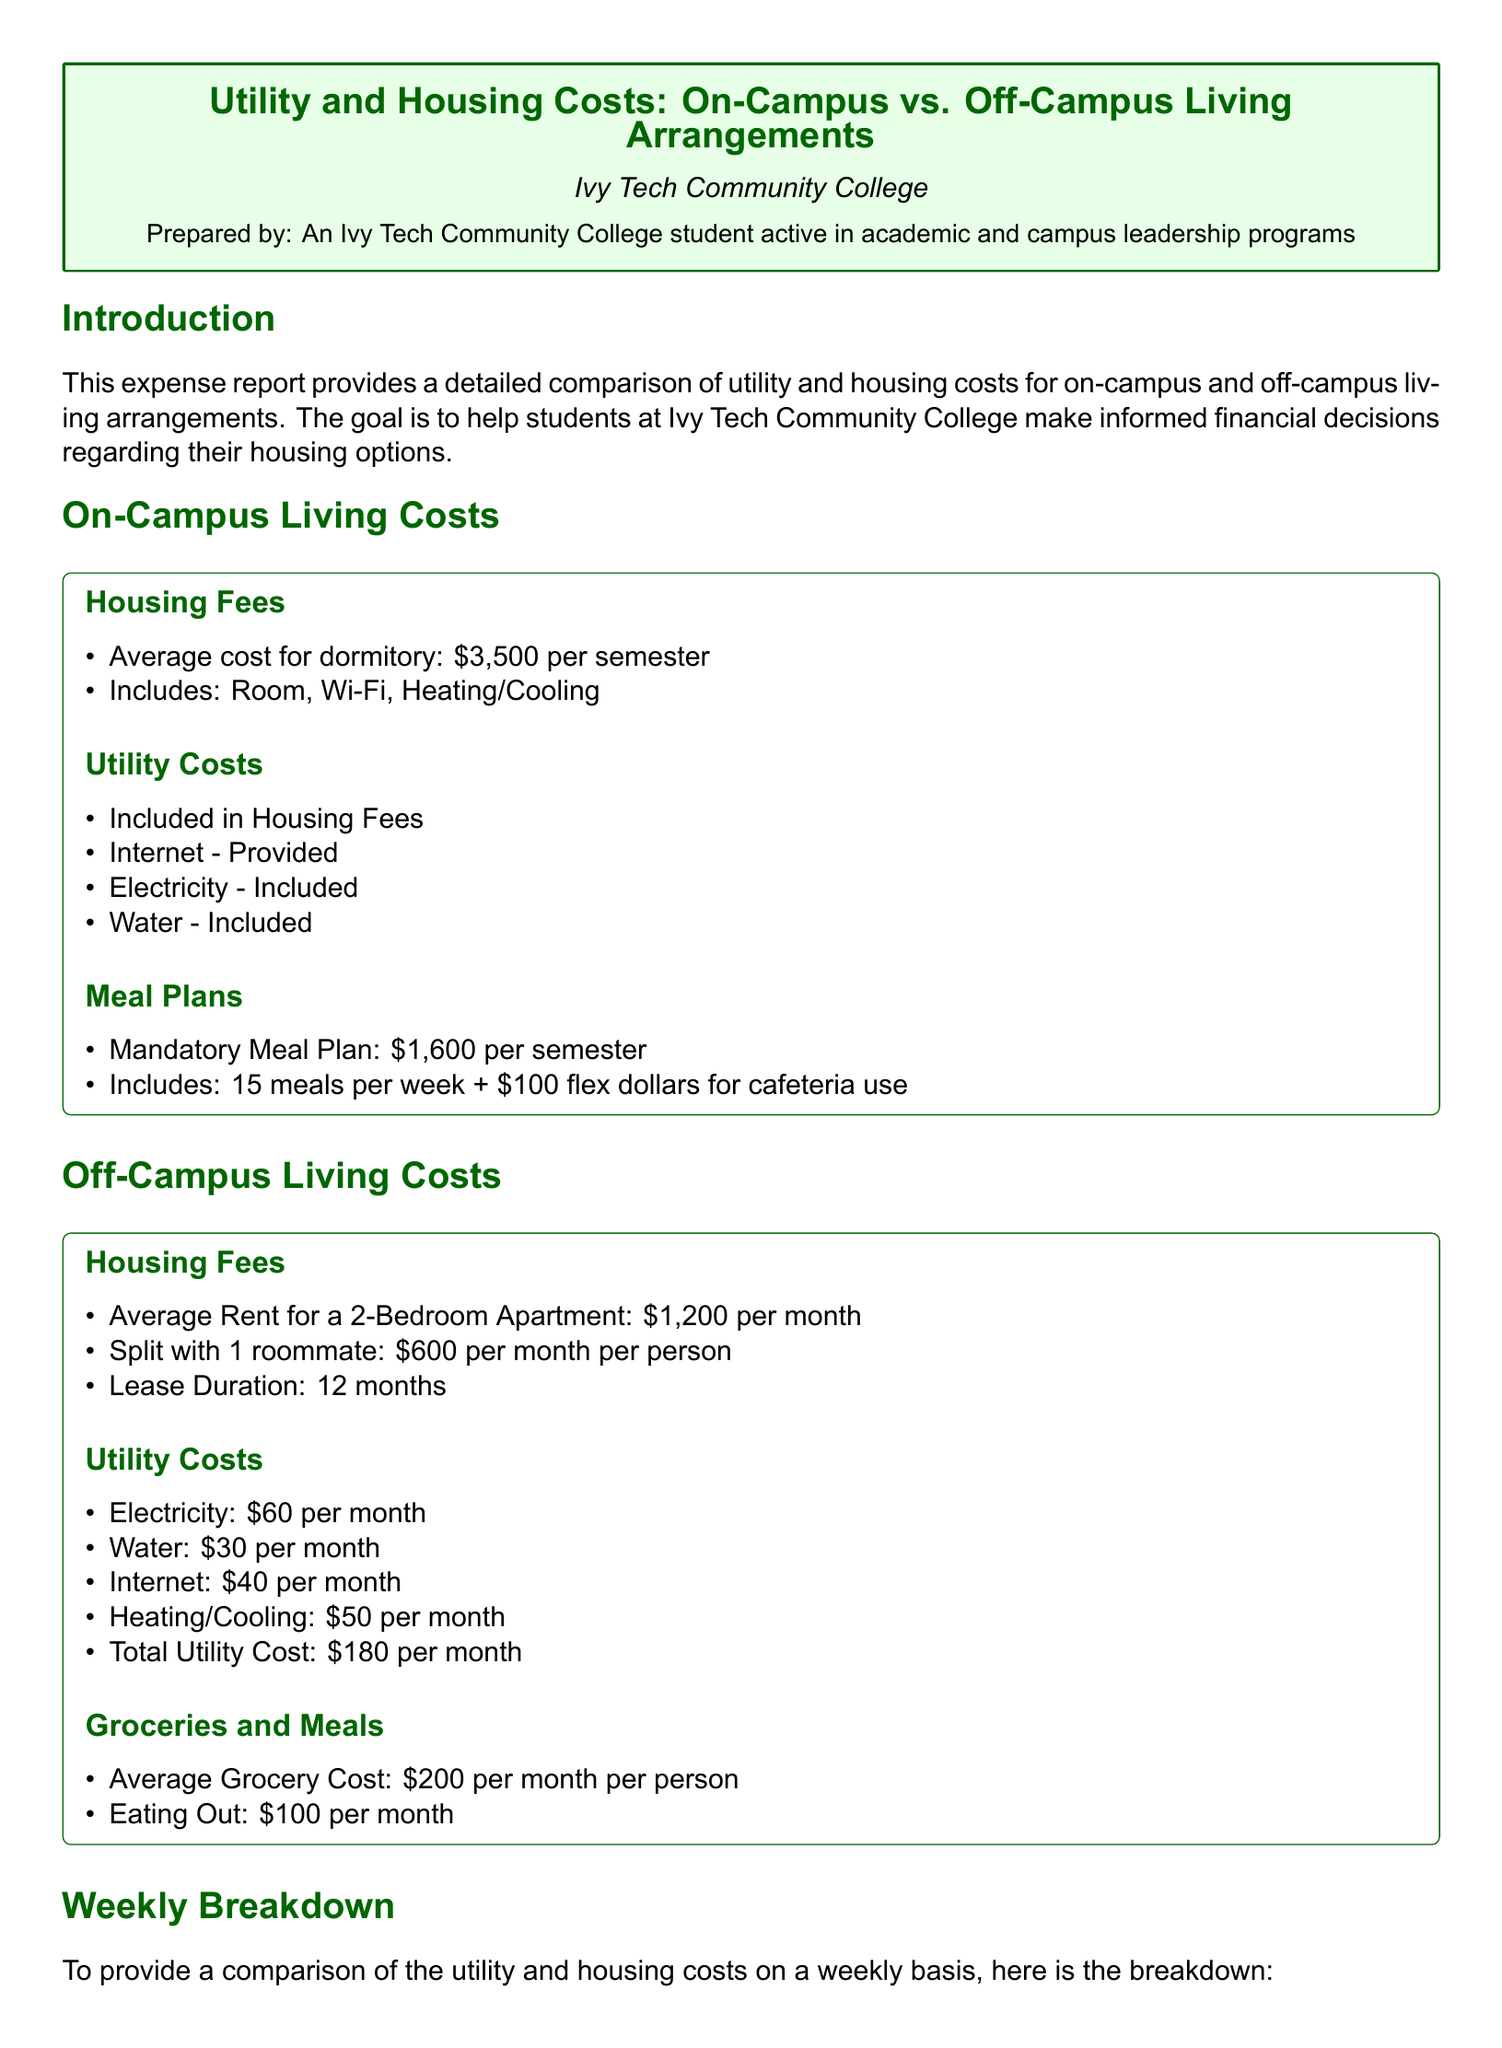What is the average cost for on-campus housing? The average cost for a dormitory is provided in the document as $3,500 per semester.
Answer: $3,500 What is included in the on-campus utility costs? The document lists that on-campus utilities include internet, electricity, and water as part of the housing fees.
Answer: Internet, Electricity, Water What is the total monthly rent for off-campus living? The document states the average rent for a 2-bedroom apartment is $1,200 per month, split with a roommate makes it $600 per month per person.
Answer: $600 How much is the mandatory meal plan for on-campus students? The mandatory meal plan cost is listed as $1,600 per semester in the document.
Answer: $1,600 What is the total weekly cost of living on-campus? The total weekly cost of on-campus living, as calculated in the report, is $318.75.
Answer: $318.75 What is the utility cost per month for off-campus living? The document states that total utility costs for off-campus living amount to $180 per month.
Answer: $180 How much do off-campus students spend on groceries and meals per month? The average grocery cost and eating out combined is given as $300 per month in the off-campus section.
Answer: $300 Which living arrangement has a higher weekly cost? The comparison in the document illustrates that on-campus living has a higher weekly cost of $318.75 compared to off-campus living.
Answer: On-campus What does the report suggest students consider when choosing their housing option? The conclusion emphasizes that students should consider their lifestyle, budget management skills, and personal preferences when making housing decisions.
Answer: Lifestyle, budget management skills, personal preferences 